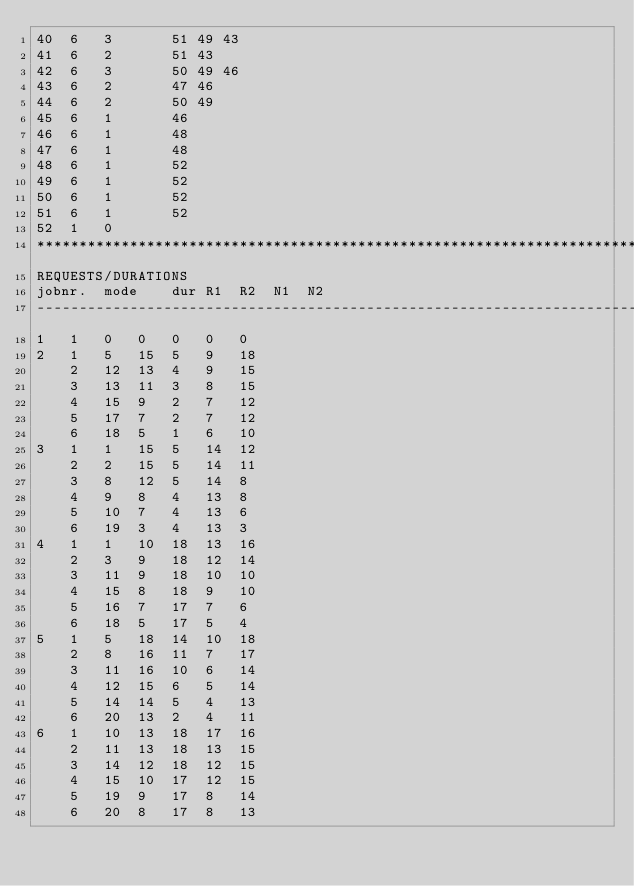Convert code to text. <code><loc_0><loc_0><loc_500><loc_500><_ObjectiveC_>40	6	3		51 49 43 
41	6	2		51 43 
42	6	3		50 49 46 
43	6	2		47 46 
44	6	2		50 49 
45	6	1		46 
46	6	1		48 
47	6	1		48 
48	6	1		52 
49	6	1		52 
50	6	1		52 
51	6	1		52 
52	1	0		
************************************************************************
REQUESTS/DURATIONS
jobnr.	mode	dur	R1	R2	N1	N2	
------------------------------------------------------------------------
1	1	0	0	0	0	0	
2	1	5	15	5	9	18	
	2	12	13	4	9	15	
	3	13	11	3	8	15	
	4	15	9	2	7	12	
	5	17	7	2	7	12	
	6	18	5	1	6	10	
3	1	1	15	5	14	12	
	2	2	15	5	14	11	
	3	8	12	5	14	8	
	4	9	8	4	13	8	
	5	10	7	4	13	6	
	6	19	3	4	13	3	
4	1	1	10	18	13	16	
	2	3	9	18	12	14	
	3	11	9	18	10	10	
	4	15	8	18	9	10	
	5	16	7	17	7	6	
	6	18	5	17	5	4	
5	1	5	18	14	10	18	
	2	8	16	11	7	17	
	3	11	16	10	6	14	
	4	12	15	6	5	14	
	5	14	14	5	4	13	
	6	20	13	2	4	11	
6	1	10	13	18	17	16	
	2	11	13	18	13	15	
	3	14	12	18	12	15	
	4	15	10	17	12	15	
	5	19	9	17	8	14	
	6	20	8	17	8	13	</code> 